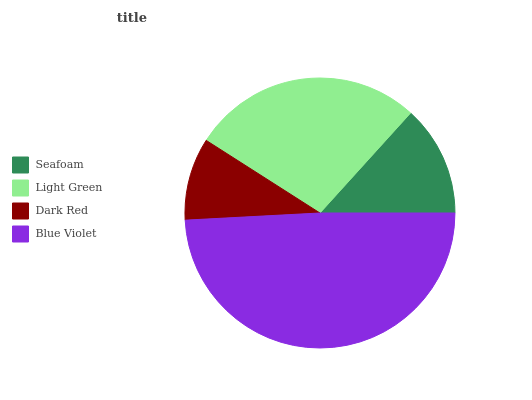Is Dark Red the minimum?
Answer yes or no. Yes. Is Blue Violet the maximum?
Answer yes or no. Yes. Is Light Green the minimum?
Answer yes or no. No. Is Light Green the maximum?
Answer yes or no. No. Is Light Green greater than Seafoam?
Answer yes or no. Yes. Is Seafoam less than Light Green?
Answer yes or no. Yes. Is Seafoam greater than Light Green?
Answer yes or no. No. Is Light Green less than Seafoam?
Answer yes or no. No. Is Light Green the high median?
Answer yes or no. Yes. Is Seafoam the low median?
Answer yes or no. Yes. Is Dark Red the high median?
Answer yes or no. No. Is Blue Violet the low median?
Answer yes or no. No. 